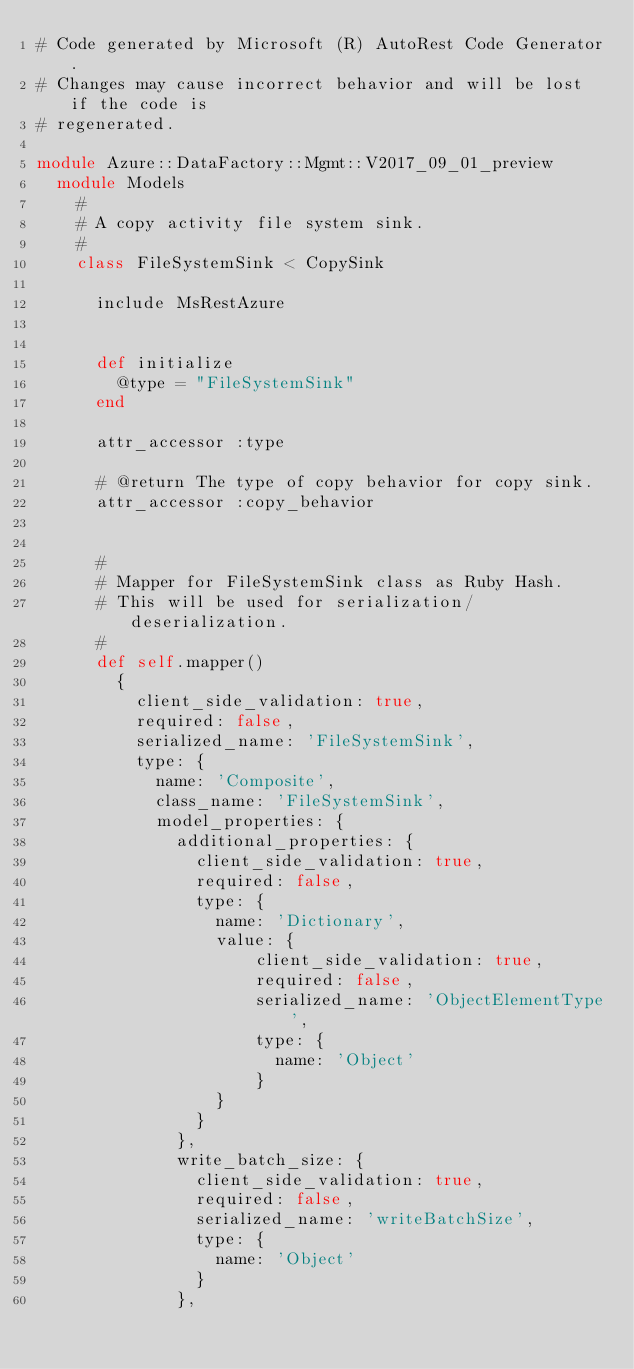<code> <loc_0><loc_0><loc_500><loc_500><_Ruby_># Code generated by Microsoft (R) AutoRest Code Generator.
# Changes may cause incorrect behavior and will be lost if the code is
# regenerated.

module Azure::DataFactory::Mgmt::V2017_09_01_preview
  module Models
    #
    # A copy activity file system sink.
    #
    class FileSystemSink < CopySink

      include MsRestAzure


      def initialize
        @type = "FileSystemSink"
      end

      attr_accessor :type

      # @return The type of copy behavior for copy sink.
      attr_accessor :copy_behavior


      #
      # Mapper for FileSystemSink class as Ruby Hash.
      # This will be used for serialization/deserialization.
      #
      def self.mapper()
        {
          client_side_validation: true,
          required: false,
          serialized_name: 'FileSystemSink',
          type: {
            name: 'Composite',
            class_name: 'FileSystemSink',
            model_properties: {
              additional_properties: {
                client_side_validation: true,
                required: false,
                type: {
                  name: 'Dictionary',
                  value: {
                      client_side_validation: true,
                      required: false,
                      serialized_name: 'ObjectElementType',
                      type: {
                        name: 'Object'
                      }
                  }
                }
              },
              write_batch_size: {
                client_side_validation: true,
                required: false,
                serialized_name: 'writeBatchSize',
                type: {
                  name: 'Object'
                }
              },</code> 